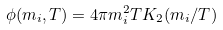<formula> <loc_0><loc_0><loc_500><loc_500>\phi ( m _ { i } , T ) = 4 \pi m _ { i } ^ { 2 } T K _ { 2 } ( m _ { i } / T )</formula> 